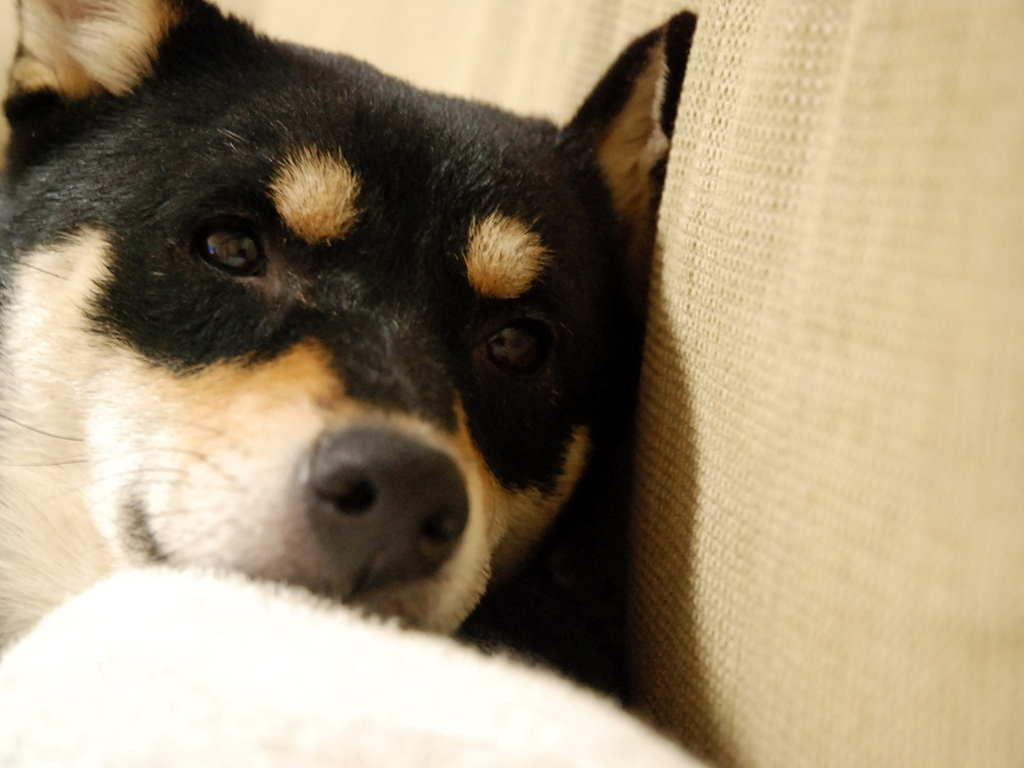Describe the composition of this photograph and how it affects the viewer's perception. The composition utilizes a shallow depth of field to focus on the dog's face, drawing the viewer's attention directly to its expression. The off-center placement of the dog creates a dynamic balance in the frame, and the blurred background minimizes distractions, enhancing the emotional impact and connection between the viewer and the subject. 